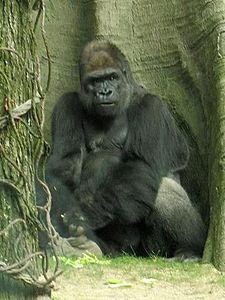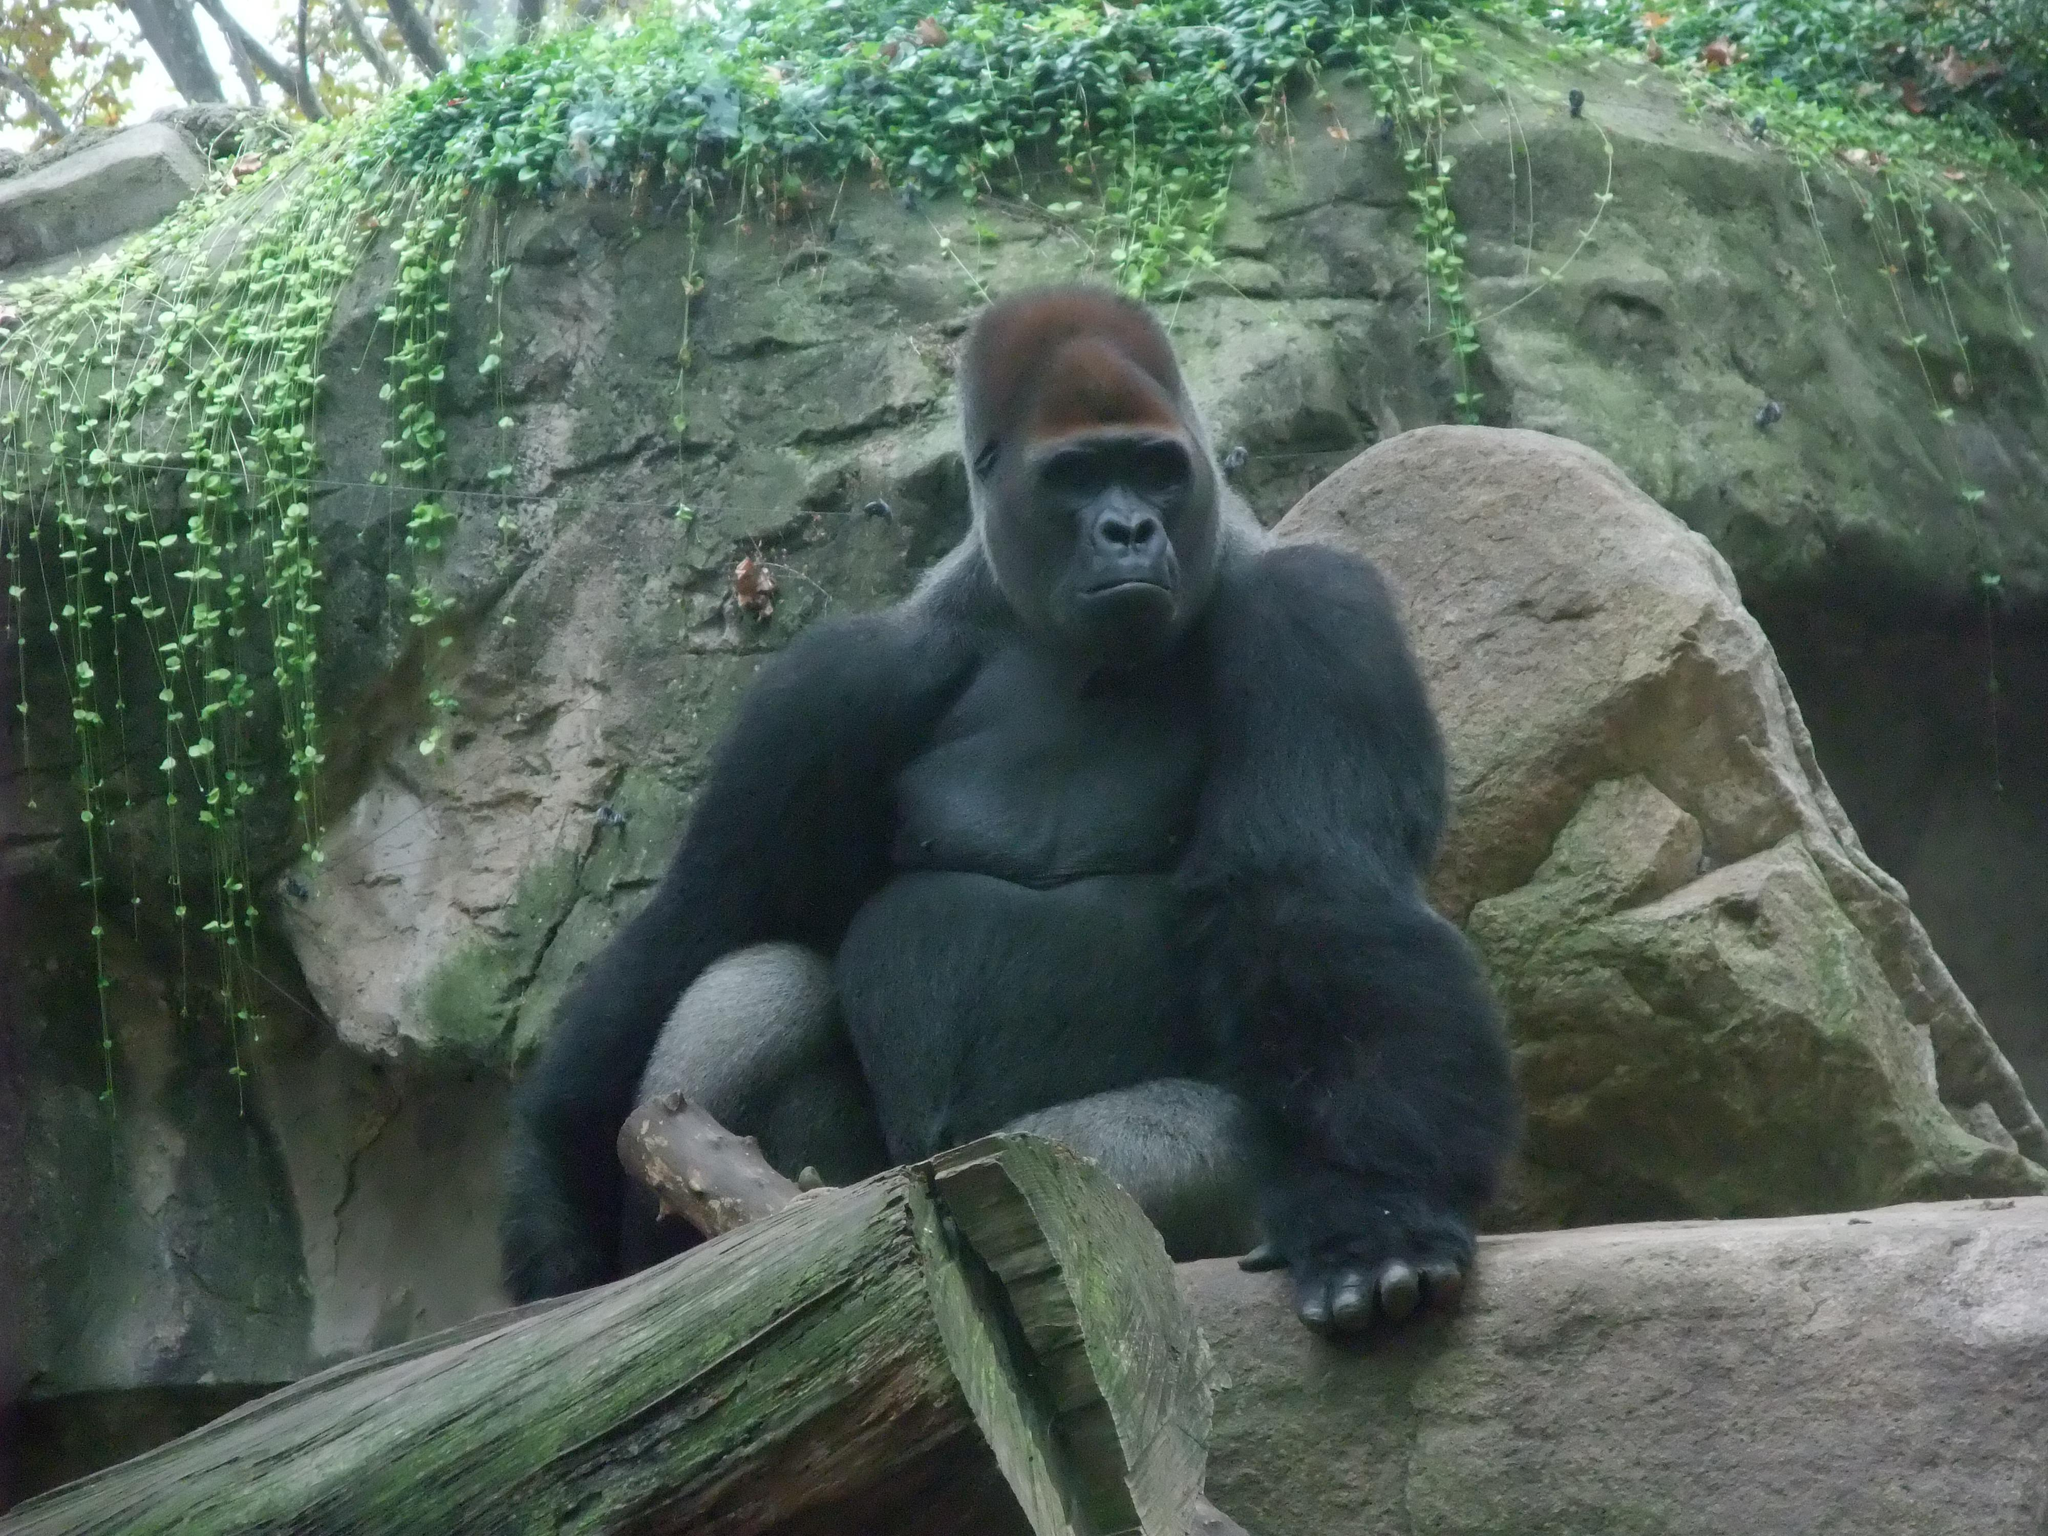The first image is the image on the left, the second image is the image on the right. For the images shown, is this caption "In the image to the right, a gorilla stands on all fours." true? Answer yes or no. No. The first image is the image on the left, the second image is the image on the right. Given the left and right images, does the statement "In the right image, there's a silverback gorilla standing on all fours." hold true? Answer yes or no. No. 